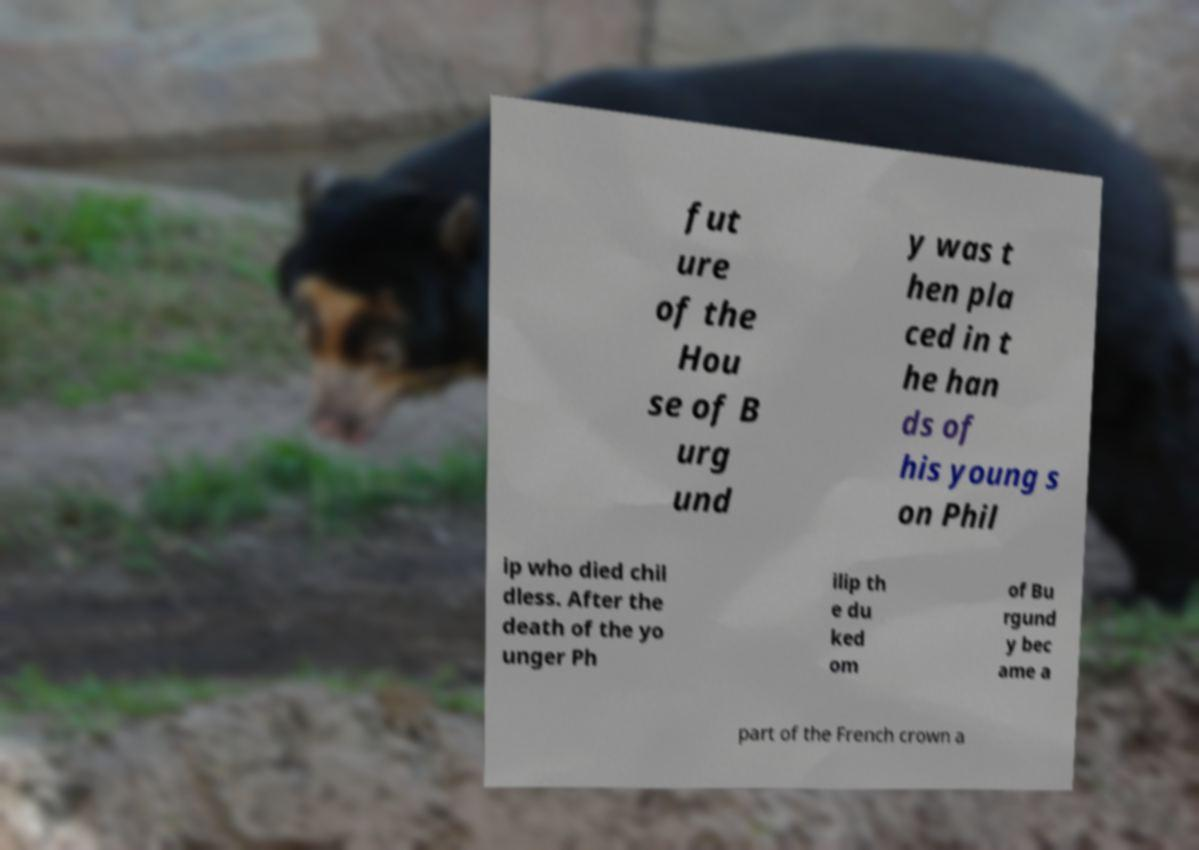For documentation purposes, I need the text within this image transcribed. Could you provide that? fut ure of the Hou se of B urg und y was t hen pla ced in t he han ds of his young s on Phil ip who died chil dless. After the death of the yo unger Ph ilip th e du ked om of Bu rgund y bec ame a part of the French crown a 